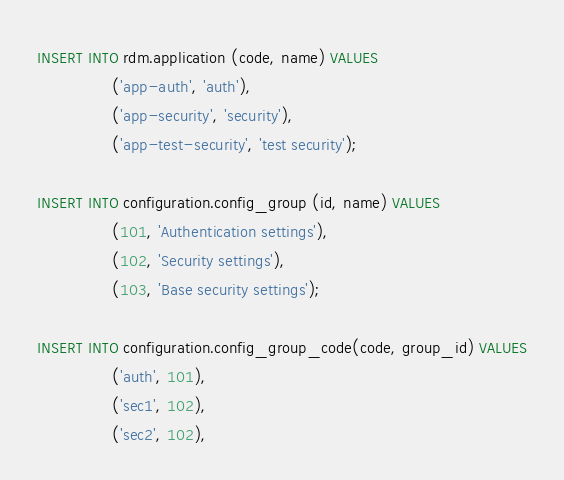<code> <loc_0><loc_0><loc_500><loc_500><_SQL_>INSERT INTO rdm.application (code, name) VALUES
                ('app-auth', 'auth'),
                ('app-security', 'security'),
                ('app-test-security', 'test security');

INSERT INTO configuration.config_group (id, name) VALUES
                (101, 'Authentication settings'),
                (102, 'Security settings'),
                (103, 'Base security settings');

INSERT INTO configuration.config_group_code(code, group_id) VALUES
                ('auth', 101),
                ('sec1', 102),
                ('sec2', 102),</code> 